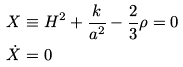Convert formula to latex. <formula><loc_0><loc_0><loc_500><loc_500>X & \equiv H ^ { 2 } + \frac { k } { a ^ { 2 } } - \frac { 2 } { 3 } \rho = 0 \\ \dot { X } & = 0</formula> 